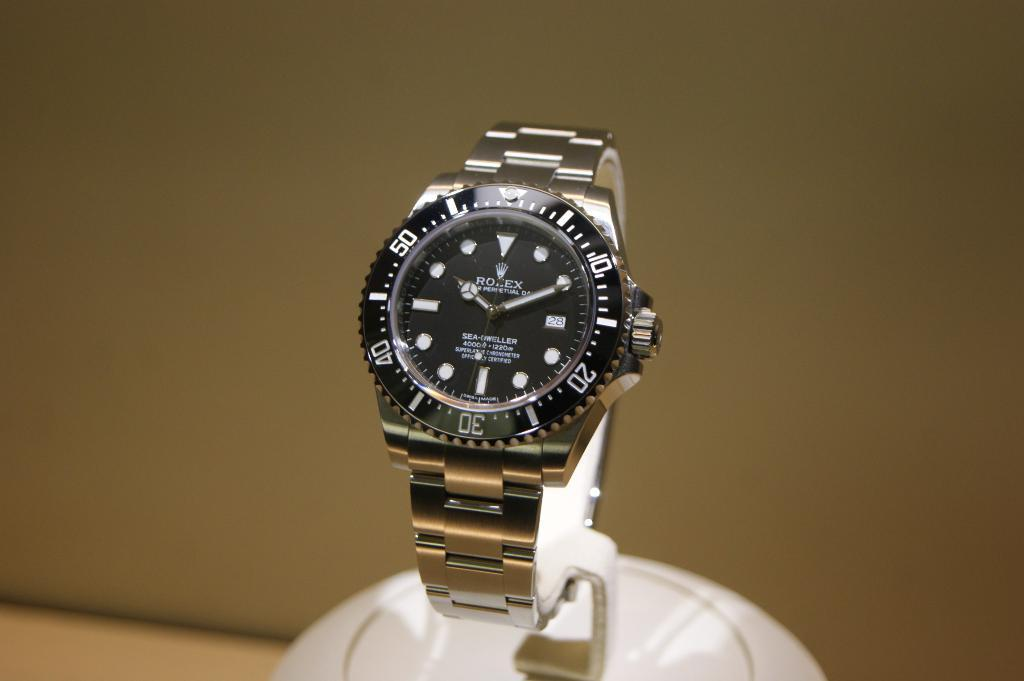<image>
Create a compact narrative representing the image presented. A black and silver wrist watch with the brand rolex on its face. 